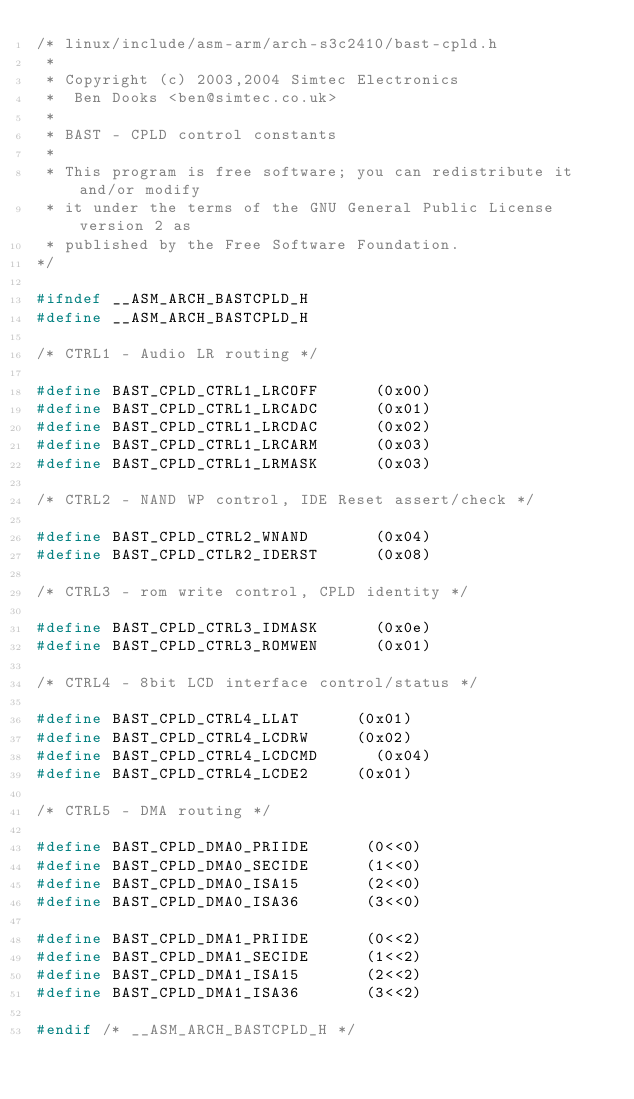<code> <loc_0><loc_0><loc_500><loc_500><_C_>/* linux/include/asm-arm/arch-s3c2410/bast-cpld.h
 *
 * Copyright (c) 2003,2004 Simtec Electronics
 *	Ben Dooks <ben@simtec.co.uk>
 *
 * BAST - CPLD control constants
 *
 * This program is free software; you can redistribute it and/or modify
 * it under the terms of the GNU General Public License version 2 as
 * published by the Free Software Foundation.
*/

#ifndef __ASM_ARCH_BASTCPLD_H
#define __ASM_ARCH_BASTCPLD_H

/* CTRL1 - Audio LR routing */

#define BAST_CPLD_CTRL1_LRCOFF	    (0x00)
#define BAST_CPLD_CTRL1_LRCADC	    (0x01)
#define BAST_CPLD_CTRL1_LRCDAC	    (0x02)
#define BAST_CPLD_CTRL1_LRCARM	    (0x03)
#define BAST_CPLD_CTRL1_LRMASK	    (0x03)

/* CTRL2 - NAND WP control, IDE Reset assert/check */

#define BAST_CPLD_CTRL2_WNAND       (0x04)
#define BAST_CPLD_CTLR2_IDERST      (0x08)

/* CTRL3 - rom write control, CPLD identity */

#define BAST_CPLD_CTRL3_IDMASK      (0x0e)
#define BAST_CPLD_CTRL3_ROMWEN      (0x01)

/* CTRL4 - 8bit LCD interface control/status */

#define BAST_CPLD_CTRL4_LLAT	    (0x01)
#define BAST_CPLD_CTRL4_LCDRW	    (0x02)
#define BAST_CPLD_CTRL4_LCDCMD	    (0x04)
#define BAST_CPLD_CTRL4_LCDE2	    (0x01)

/* CTRL5 - DMA routing */

#define BAST_CPLD_DMA0_PRIIDE      (0<<0)
#define BAST_CPLD_DMA0_SECIDE      (1<<0)
#define BAST_CPLD_DMA0_ISA15       (2<<0)
#define BAST_CPLD_DMA0_ISA36       (3<<0)

#define BAST_CPLD_DMA1_PRIIDE      (0<<2)
#define BAST_CPLD_DMA1_SECIDE      (1<<2)
#define BAST_CPLD_DMA1_ISA15       (2<<2)
#define BAST_CPLD_DMA1_ISA36       (3<<2)

#endif /* __ASM_ARCH_BASTCPLD_H */
</code> 